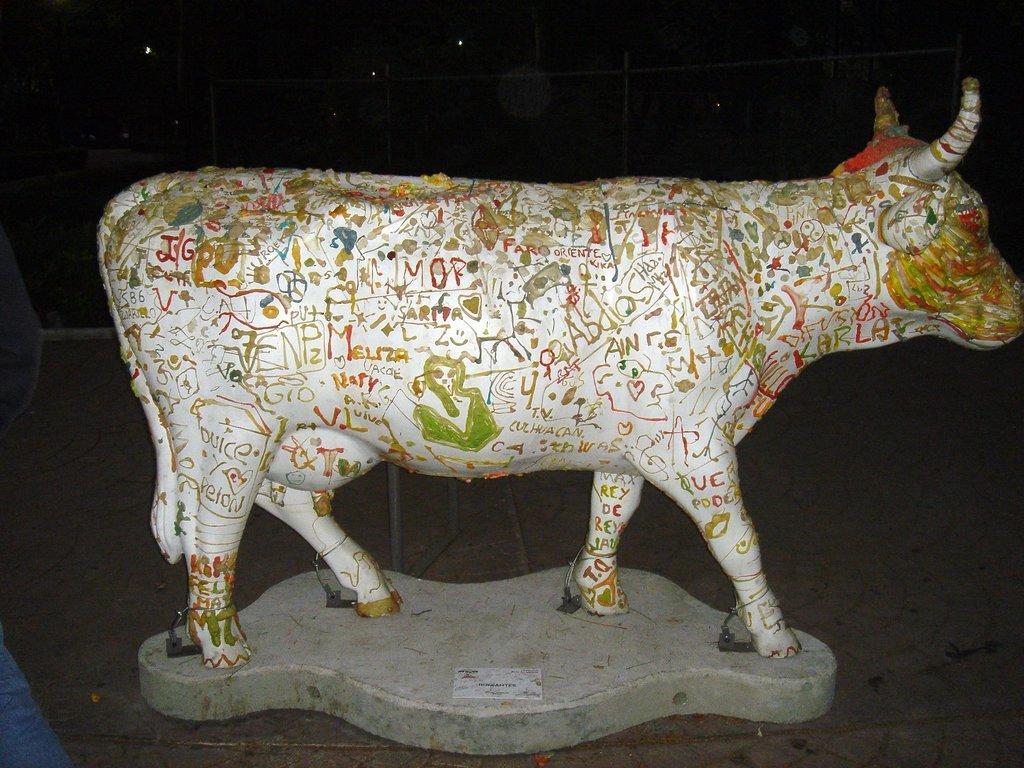Could you give a brief overview of what you see in this image? This picture seems to be clicked outside. In the foreground we can see the sculpture of an animal and we can see the text and some drawings on the animal. In the background we can see the lights, metal rods and many other objects. 